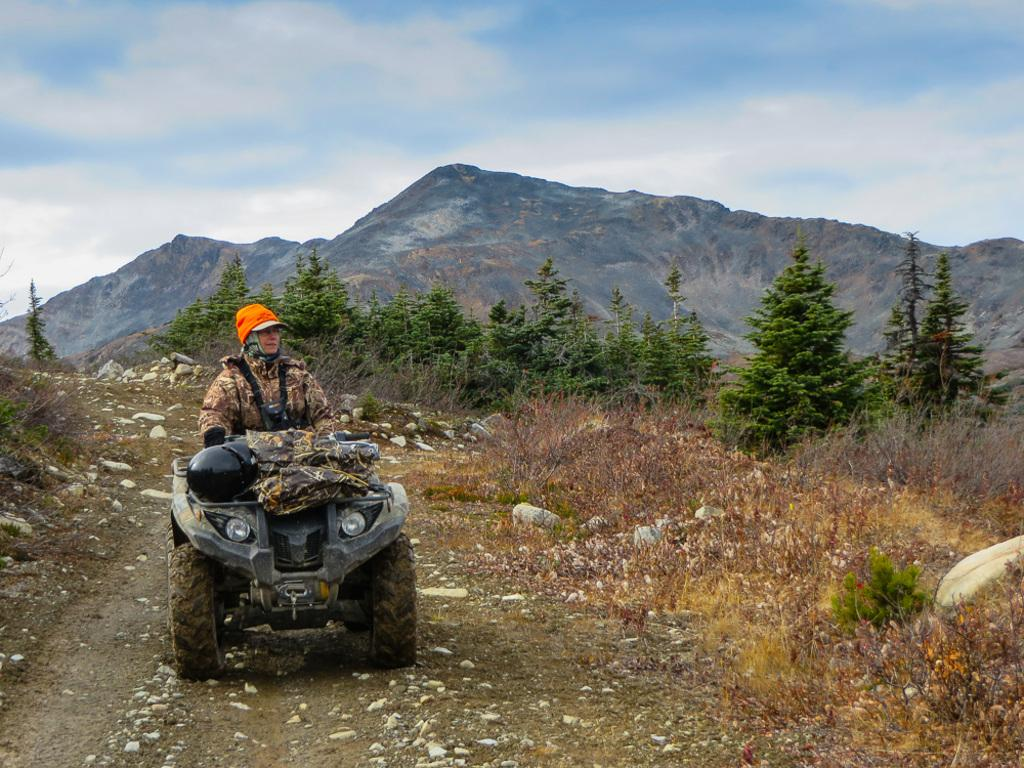What is the main subject of the image? There is a person in a vehicle in the image. What type of natural environment can be seen in the image? Trees, stones, and mountains are visible in the image. What flavor of ice cream is the person in the vehicle enjoying in the image? There is no ice cream present in the image, so it is not possible to determine the flavor. 